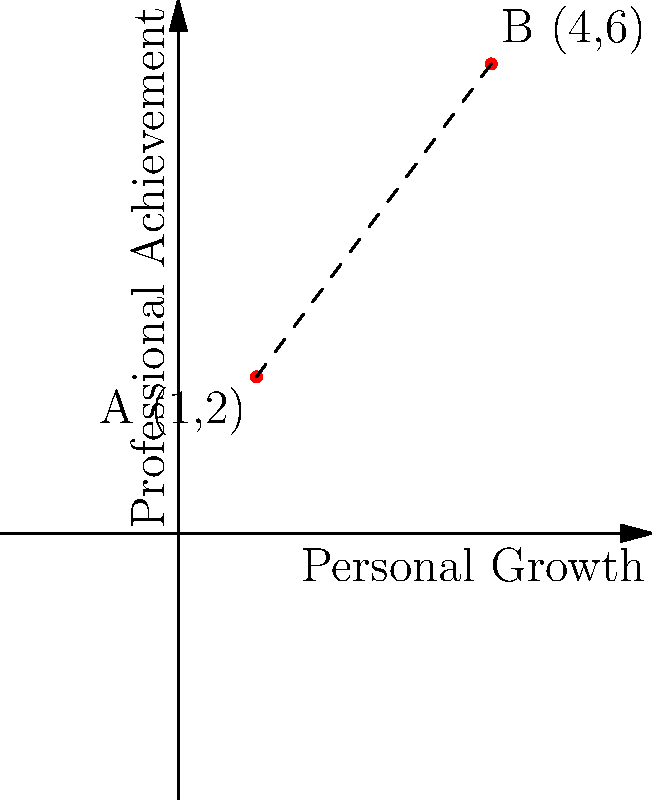In your journey of personal and professional growth, you've mapped two significant milestones on a coordinate plane. The first milestone, representing where you started, is at point A (1,2). Your current position, after implementing strategies from your self-help book, is at point B (4,6). Calculate the distance between these two points to quantify your growth. Round your answer to two decimal places. To calculate the distance between two points, we can use the distance formula, which is derived from the Pythagorean theorem:

$$ d = \sqrt{(x_2 - x_1)^2 + (y_2 - y_1)^2} $$

Where $(x_1, y_1)$ are the coordinates of the first point and $(x_2, y_2)$ are the coordinates of the second point.

Given:
Point A (start): $(1, 2)$
Point B (current): $(4, 6)$

Let's plug these values into the formula:

$$ d = \sqrt{(4 - 1)^2 + (6 - 2)^2} $$

Simplify:
$$ d = \sqrt{3^2 + 4^2} $$
$$ d = \sqrt{9 + 16} $$
$$ d = \sqrt{25} $$
$$ d = 5 $$

The exact distance is 5 units. Since we're asked to round to two decimal places, our final answer is 5.00.
Answer: 5.00 units 